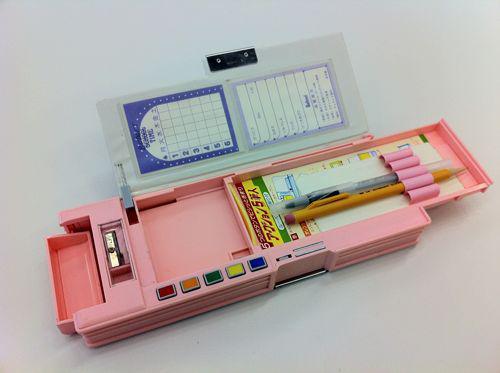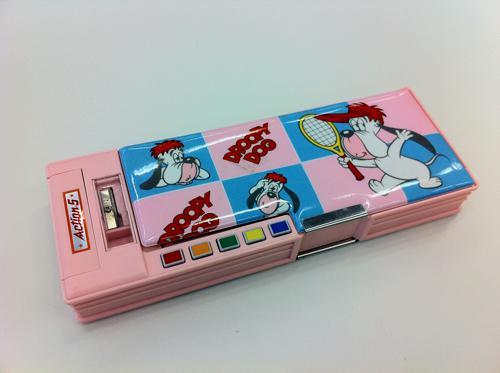The first image is the image on the left, the second image is the image on the right. Analyze the images presented: Is the assertion "One image features soft-sided tube-shaped pencil cases with a zipper on top." valid? Answer yes or no. No. The first image is the image on the left, the second image is the image on the right. Analyze the images presented: Is the assertion "There is exactly one open pencil case in the image on the right." valid? Answer yes or no. No. 